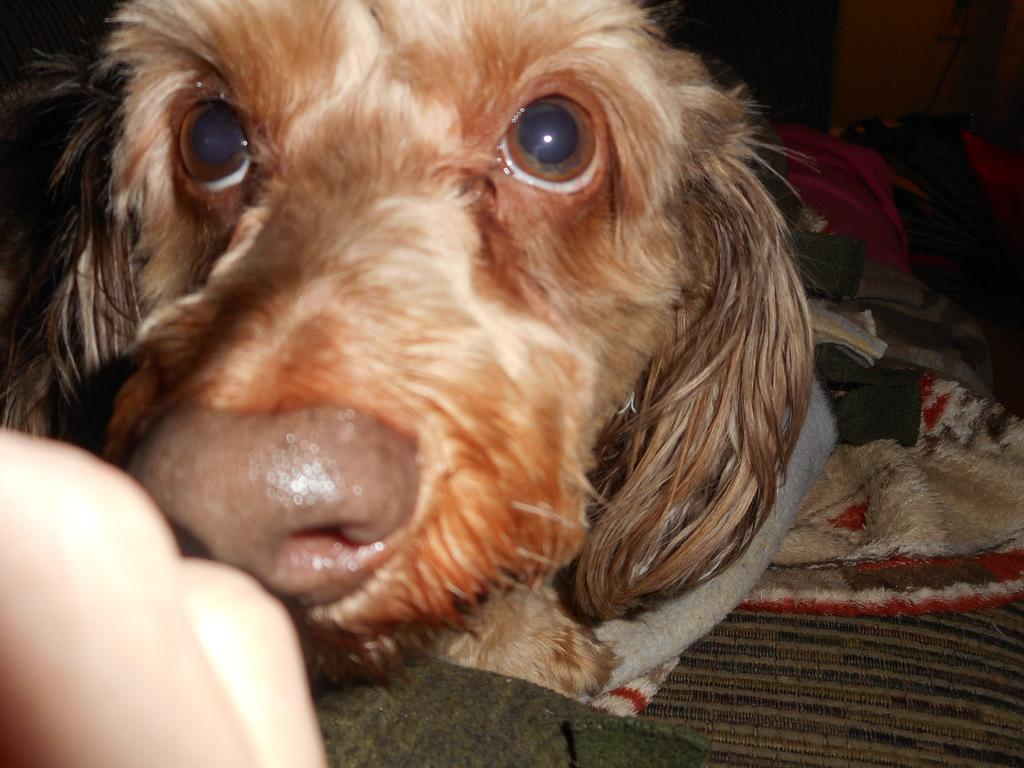What type of animal is in the image? There is a dog in the image. Can you describe the dog's appearance? The dog is brown and black in color. What else can be seen in the image? There is a human hand in the bottom left side of the image. What is the overall color scheme of the image? The background of the image is dark. What type of owl can be seen in the image? There is no owl present in the image; it features a dog. How does the toothpaste change the color of the dog's fur in the image? There is no toothpaste mentioned in the image, and the dog's fur color is described as brown and black. 